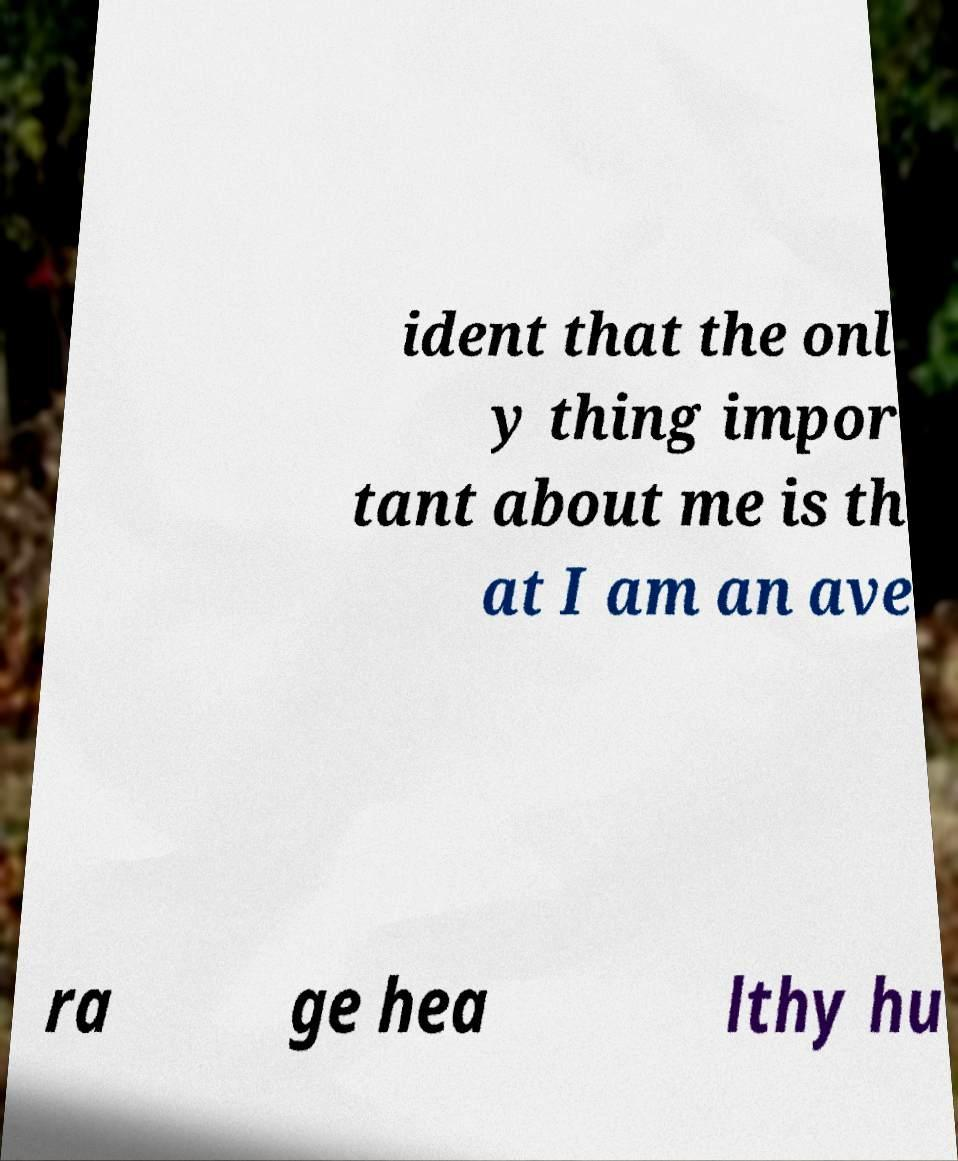Could you assist in decoding the text presented in this image and type it out clearly? ident that the onl y thing impor tant about me is th at I am an ave ra ge hea lthy hu 